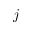<formula> <loc_0><loc_0><loc_500><loc_500>j</formula> 